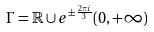Convert formula to latex. <formula><loc_0><loc_0><loc_500><loc_500>\Gamma = \mathbb { R } \cup e ^ { \pm \frac { 2 \pi i } { 3 } } ( 0 , + \infty )</formula> 